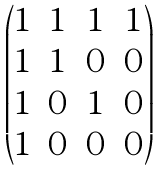<formula> <loc_0><loc_0><loc_500><loc_500>\begin{pmatrix} 1 & 1 & 1 & 1 \\ 1 & 1 & 0 & 0 \\ 1 & 0 & 1 & 0 \\ 1 & 0 & 0 & 0 \end{pmatrix}</formula> 